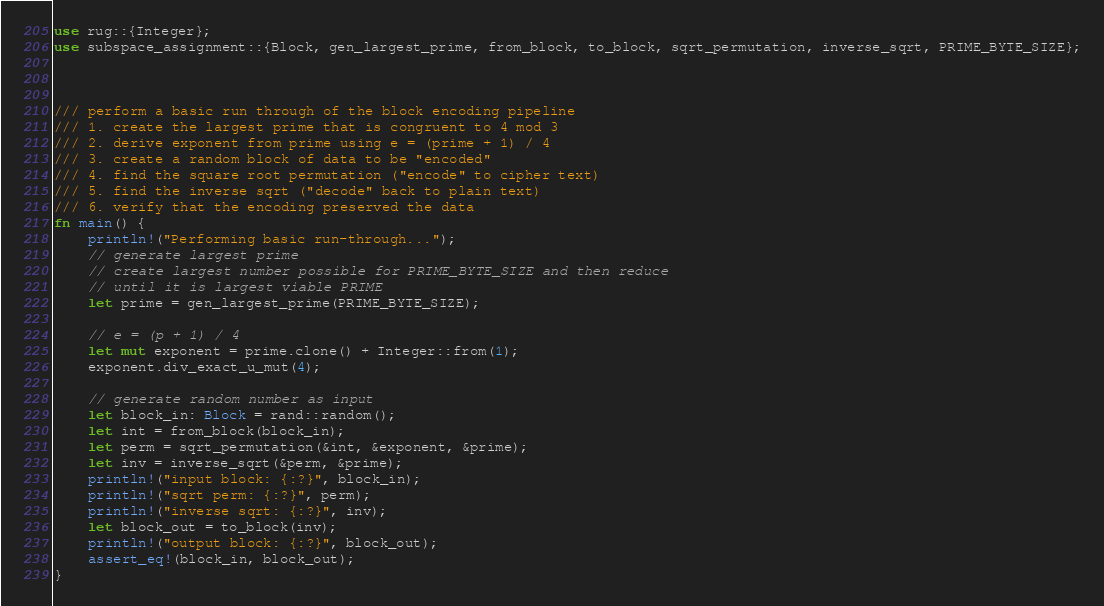<code> <loc_0><loc_0><loc_500><loc_500><_Rust_>use rug::{Integer};
use subspace_assignment::{Block, gen_largest_prime, from_block, to_block, sqrt_permutation, inverse_sqrt, PRIME_BYTE_SIZE};



/// perform a basic run through of the block encoding pipeline
/// 1. create the largest prime that is congruent to 4 mod 3
/// 2. derive exponent from prime using e = (prime + 1) / 4
/// 3. create a random block of data to be "encoded"
/// 4. find the square root permutation ("encode" to cipher text)
/// 5. find the inverse sqrt ("decode" back to plain text)
/// 6. verify that the encoding preserved the data
fn main() {
    println!("Performing basic run-through...");
    // generate largest prime
    // create largest number possible for PRIME_BYTE_SIZE and then reduce
    // until it is largest viable PRIME
    let prime = gen_largest_prime(PRIME_BYTE_SIZE);

    // e = (p + 1) / 4
    let mut exponent = prime.clone() + Integer::from(1);
    exponent.div_exact_u_mut(4);

    // generate random number as input
    let block_in: Block = rand::random();
    let int = from_block(block_in);
    let perm = sqrt_permutation(&int, &exponent, &prime);
    let inv = inverse_sqrt(&perm, &prime);
    println!("input block: {:?}", block_in);
    println!("sqrt perm: {:?}", perm);
    println!("inverse sqrt: {:?}", inv);
    let block_out = to_block(inv);
    println!("output block: {:?}", block_out);
    assert_eq!(block_in, block_out);
} </code> 